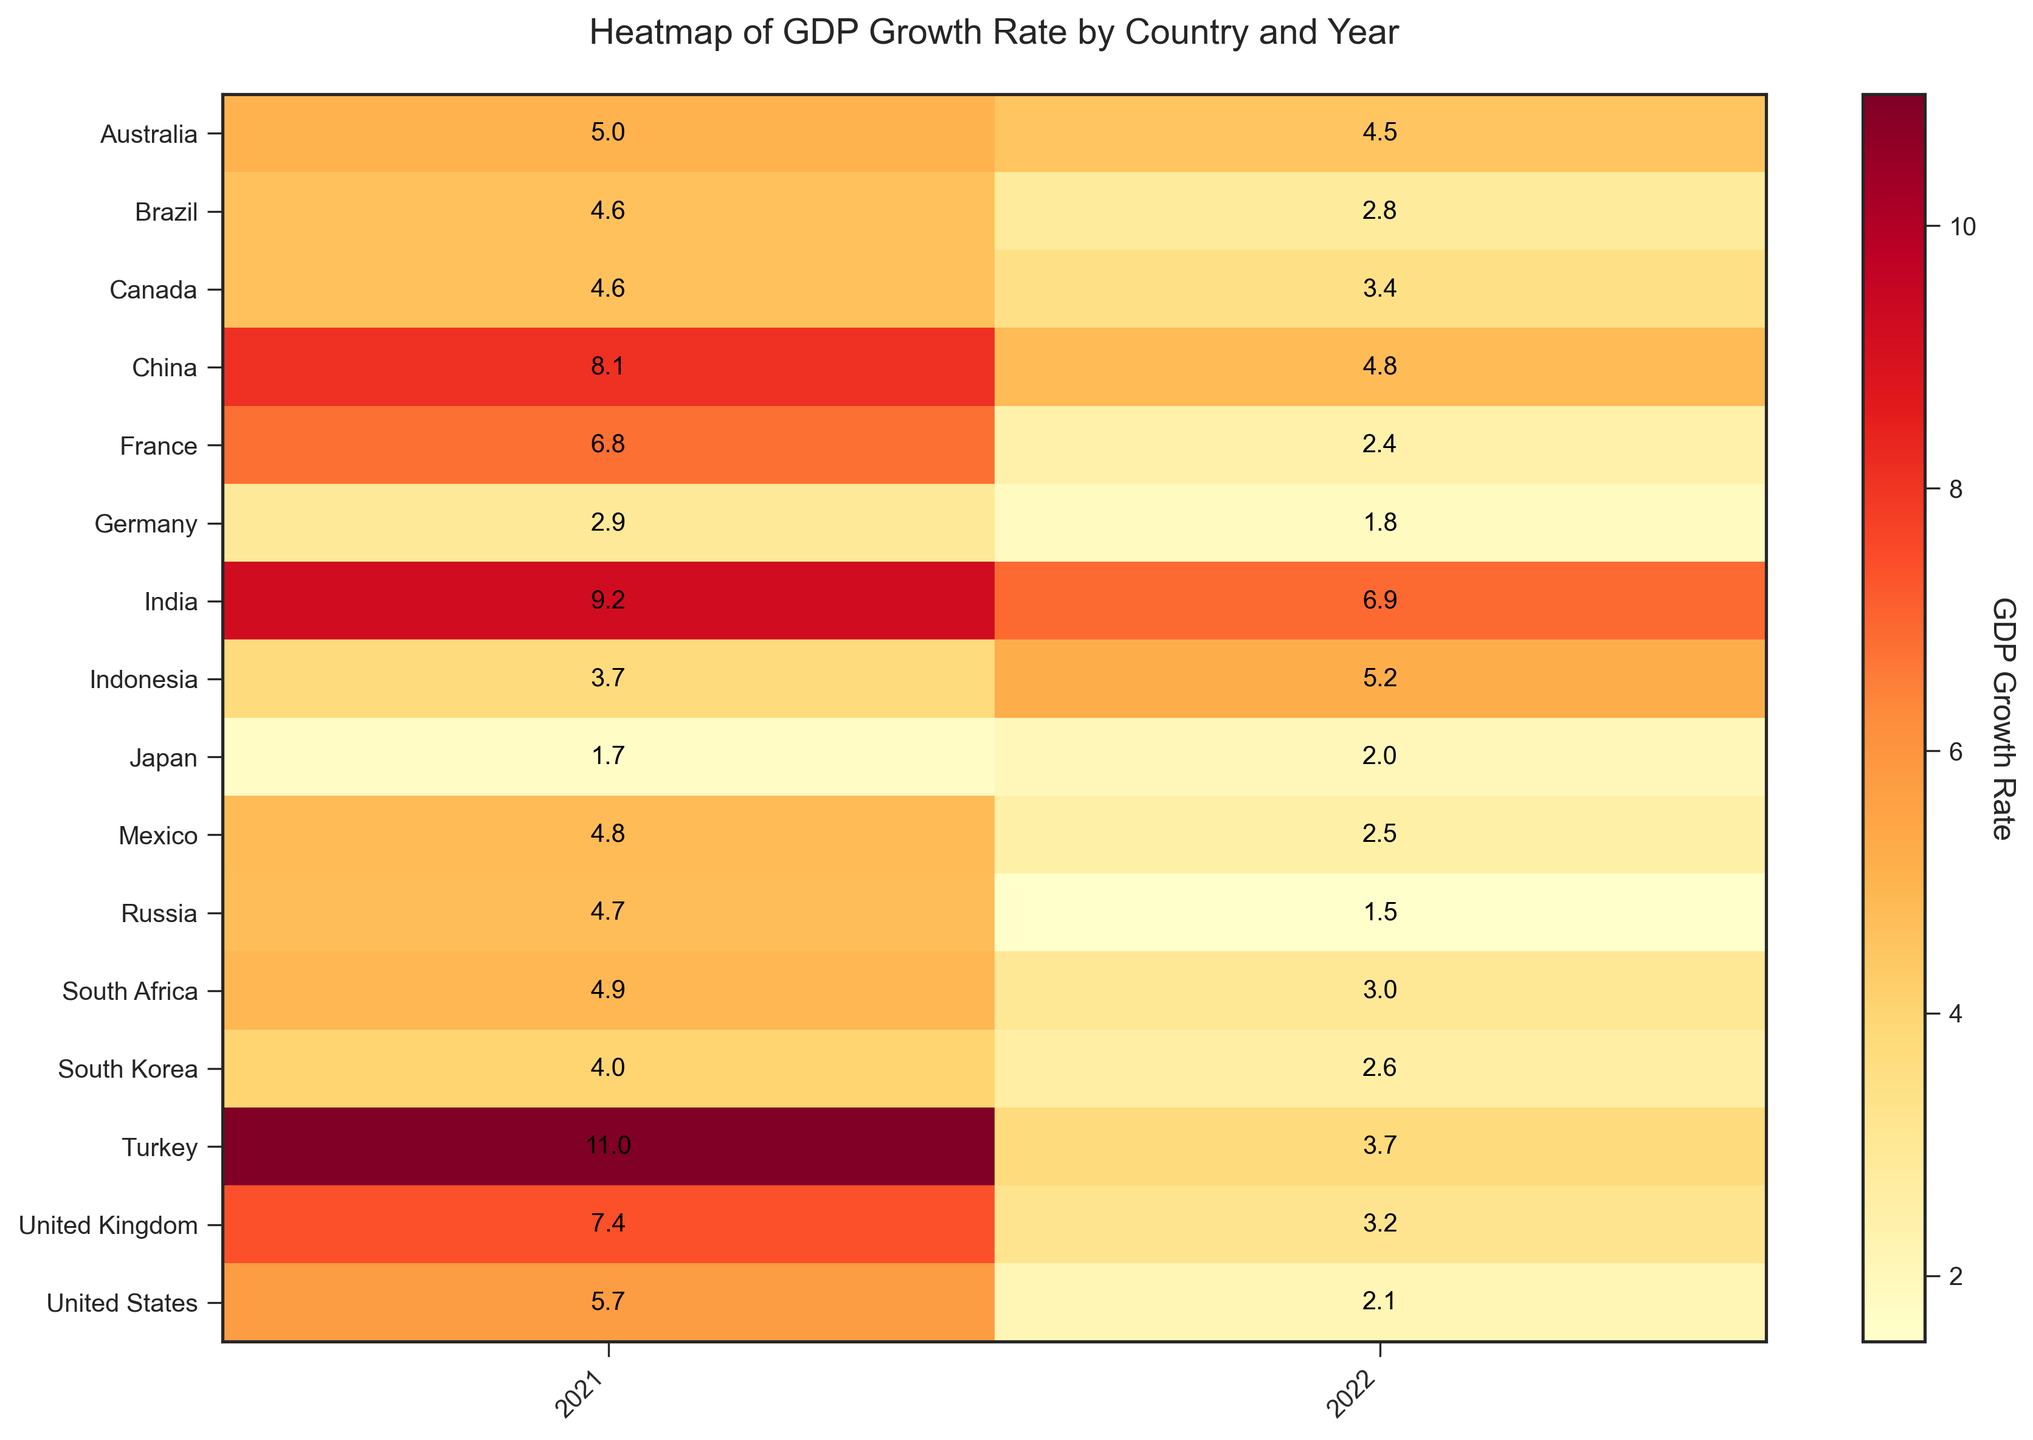Which country had the highest GDP growth rate in 2021? By observing the heatmap, look for the highest numerical value in the 2021 column. The highest value is 11.0, found in Turkey.
Answer: Turkey What is the GDP growth rate difference between Germany in 2021 and 2022? Identify Germany in the heatmap and subtract the GDP growth rate in 2022 (1.8) from that in 2021 (2.9). The difference is 2.9 - 1.8 = 1.1.
Answer: 1.1 Which country had a higher GDP growth rate in 2022: Brazil or South Africa? Compare the GDP growth rate values for Brazil (2.8) and South Africa (3.0) in 2022 from the heatmap. South Africa has a higher rate.
Answer: South Africa What is the average GDP growth rate for developed countries in 2022? Identify the GDP growth rates for all developed countries in 2022: United States (2.1), Germany (1.8), Japan (2.0), United Kingdom (3.2), France (2.4), Canada (3.4), Australia (4.5), South Korea (2.6). Calculate the average: (2.1 + 1.8 + 2.0 + 3.2 + 2.4 + 3.4 + 4.5 + 2.6) / 8 ≈ 2.75.
Answer: 2.75 Which year showed more GDP growth rate variability among emerging markets? Compare the spreads in GDP growth rates for emerging markets between 2021 and 2022. In 2021, rates range from Russia (4.7) to Turkey (11.0), and in 2022, from Russia (1.5) to India (6.9). The wider spread in 2021 (6.3) indicates more variability compared to 2022 (5.4).
Answer: 2021 How does the GDP growth rate of India in 2021 compare to that of China in the same year? Look at the GDP growth rates of India (9.2) and China (8.1) in 2021 from the heatmap. India's rate is higher.
Answer: India What was the trend in GDP growth rate for the United Kingdom from 2021 to 2022? On the heatmap, observe the change in the UK's GDP growth rate from 2021 (7.4) to 2022 (3.2). It shows a decreasing trend.
Answer: Decreasing Which emerging market had the lowest GDP growth rate in 2022? Look for the lowest value among emerging markets in the 2022 column. The lowest rate is 1.5 in Russia.
Answer: Russia What is the sum of the GDP growth rates of South Korea in 2021 and 2022? From the heatmap, find South Korea's GDP growth rates in 2021 (4.0) and 2022 (2.6). Add them: 4.0 + 2.6 = 6.6.
Answer: 6.6 Which country experienced a greater GDP growth rate decrease from 2021 to 2022, India or Turkey? Calculate the growth rate decrease for India: 9.2 (2021) - 6.9 (2022) = 2.3 and for Turkey: 11.0 (2021) - 3.7 (2022) = 7.3. Turkey experienced a greater decrease.
Answer: Turkey 